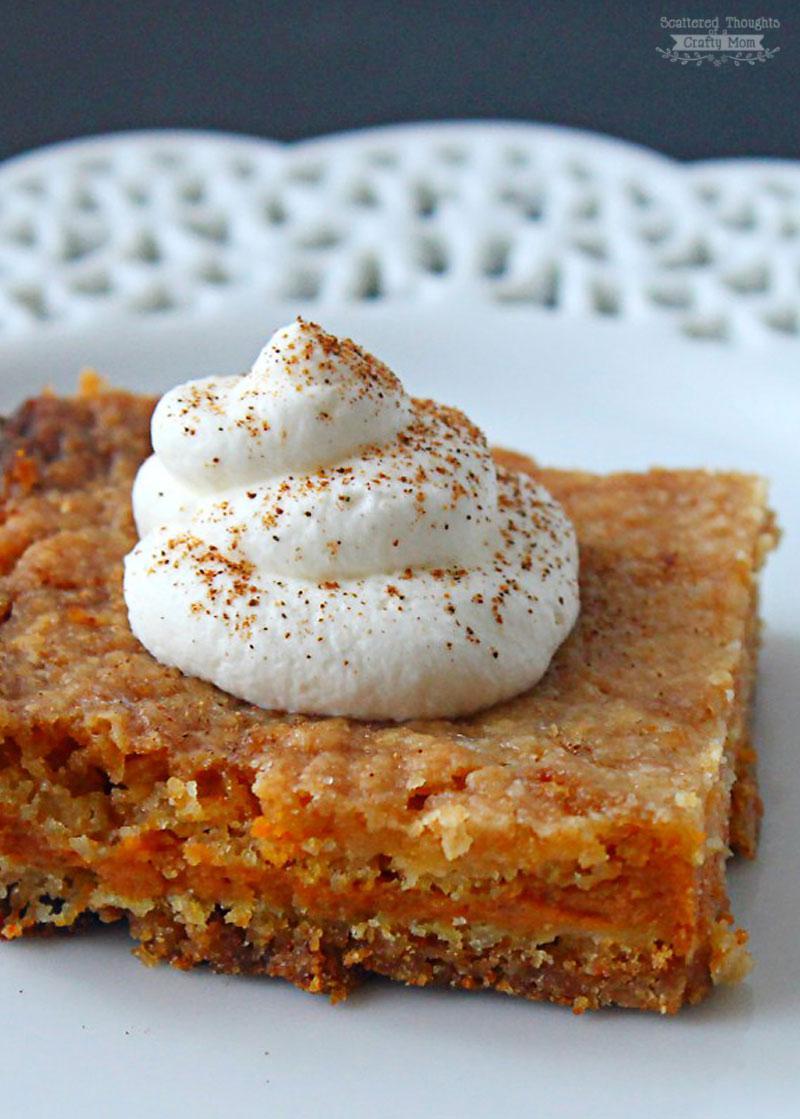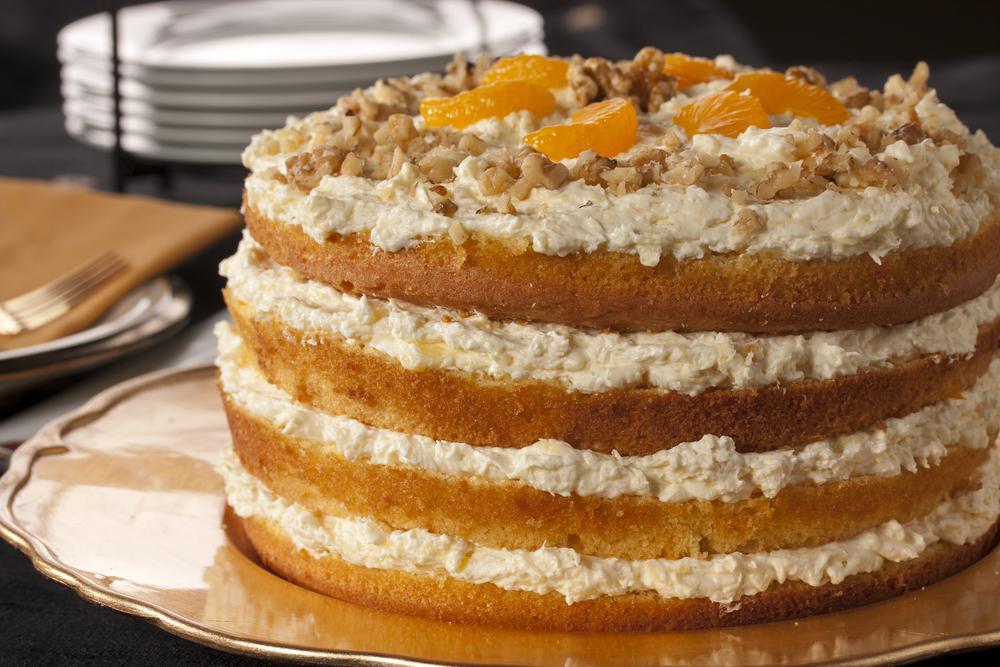The first image is the image on the left, the second image is the image on the right. Considering the images on both sides, is "One image shows one dessert slice with white on its top, and the other image shows a dessert on a round plate consisting of round layers alternating with creamy layers." valid? Answer yes or no. Yes. The first image is the image on the left, the second image is the image on the right. Examine the images to the left and right. Is the description "A cake with multiple layers is sitting on a plate in one image, while a single serving of a different dessert in the second image." accurate? Answer yes or no. Yes. 